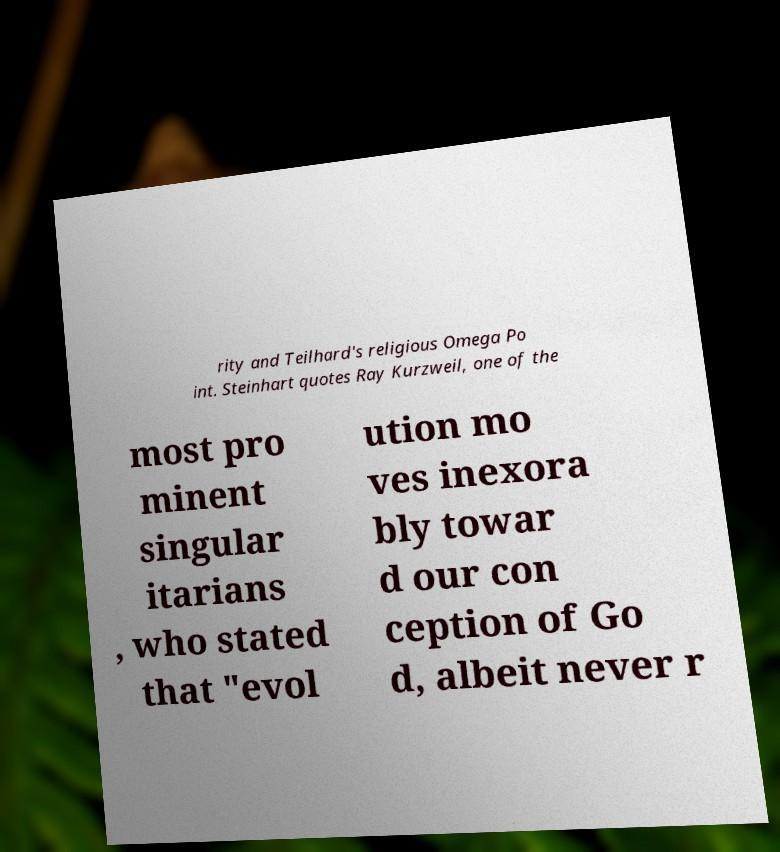What messages or text are displayed in this image? I need them in a readable, typed format. rity and Teilhard's religious Omega Po int. Steinhart quotes Ray Kurzweil, one of the most pro minent singular itarians , who stated that "evol ution mo ves inexora bly towar d our con ception of Go d, albeit never r 